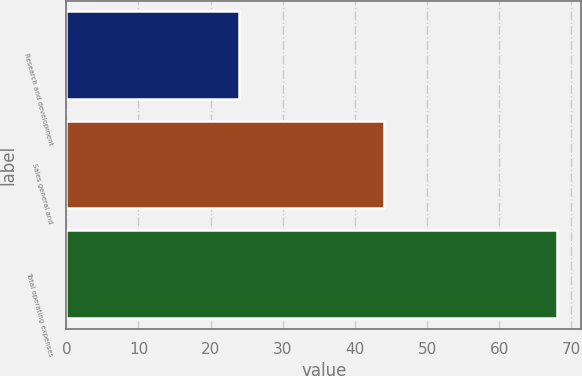<chart> <loc_0><loc_0><loc_500><loc_500><bar_chart><fcel>Research and development<fcel>Sales general and<fcel>Total operating expenses<nl><fcel>24<fcel>44<fcel>68<nl></chart> 